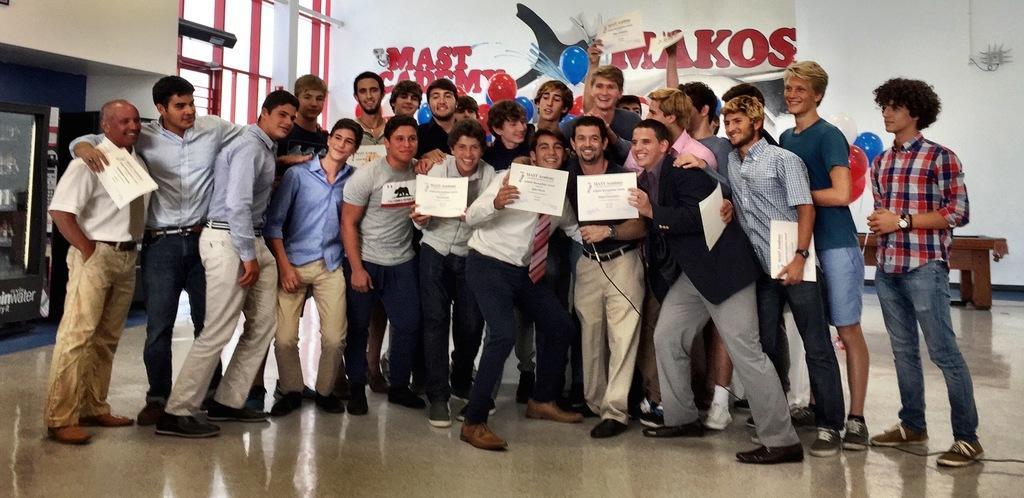Can you describe this image briefly? In this image I can see group of people are standing. In the background I can see a wall which has something written on it. Here I can see wooden object on the floor. 